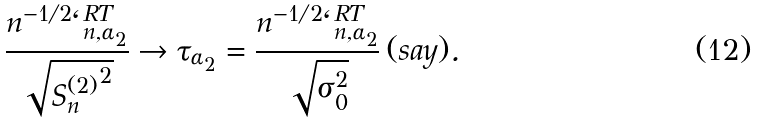Convert formula to latex. <formula><loc_0><loc_0><loc_500><loc_500>\frac { n ^ { - 1 / 2 } \ell _ { n , \alpha _ { 2 } } ^ { R T } } { \sqrt { { S _ { n } ^ { ( 2 ) } } ^ { 2 } } } \rightarrow \tau _ { \alpha _ { 2 } } = \frac { n ^ { - 1 / 2 } \ell _ { n , \alpha _ { 2 } } ^ { R T } } { \sqrt { \sigma _ { 0 } ^ { 2 } } } \, ( s a y ) .</formula> 